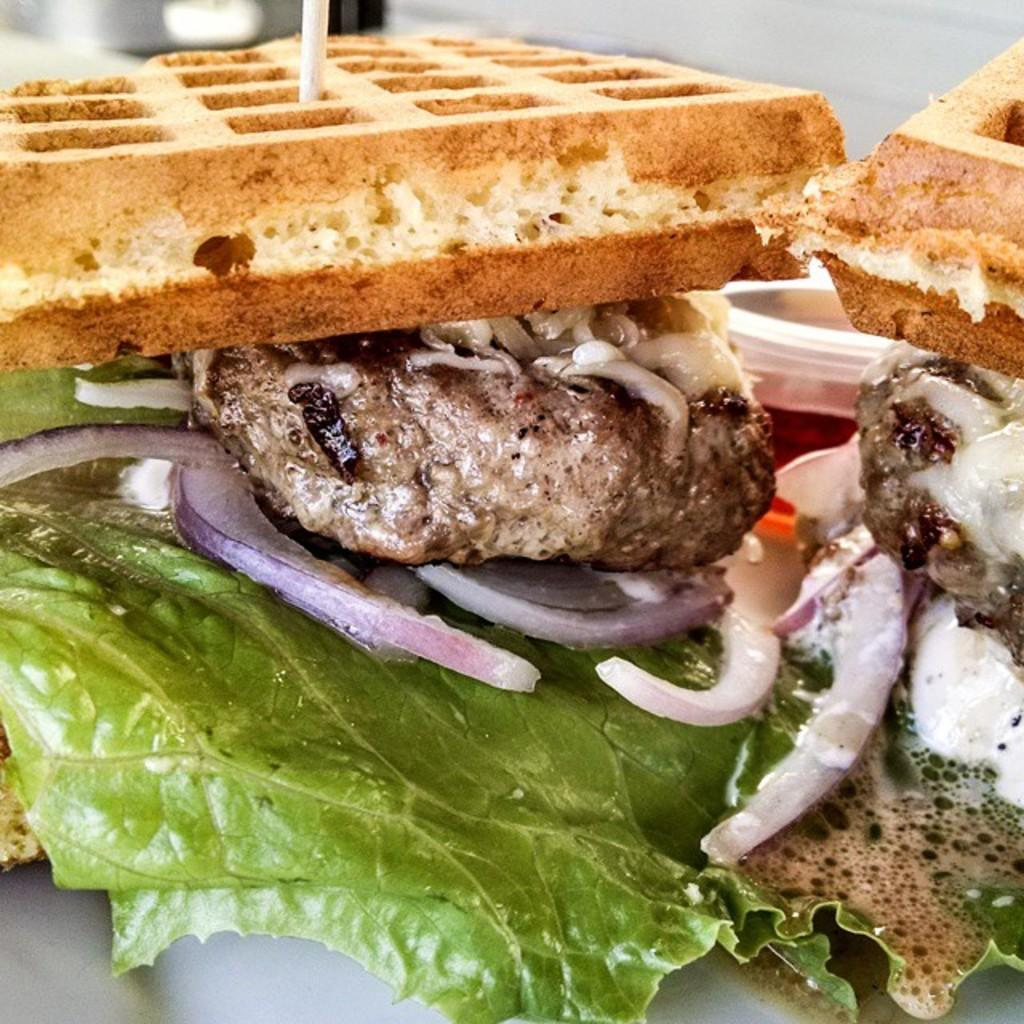What is the main object in the center of the image? There is a plastic box in the center of the image. What is inside the plastic box? There are food items in the plastic box. Can you identify any specific types of food items in the box? Yes, onion slices, leafy vegetables, and breads are among the food items. Reasoning: Let' Let's think step by step in order to produce the conversation. We start by identifying the main object in the image, which is the plastic box. Then, we describe what is inside the box, which are food items. Finally, we provide specific examples of the food items that can be seen in the image, such as onion slices, leafy vegetables, and breads. Absurd Question/Answer: Are there any cows grazing on the slope in the image? There is no slope or cows present in the image; it features a plastic box with food items. Are there any plants growing on the slope in the image? There is no slope or plants present in the image; it features a plastic box with food items. 